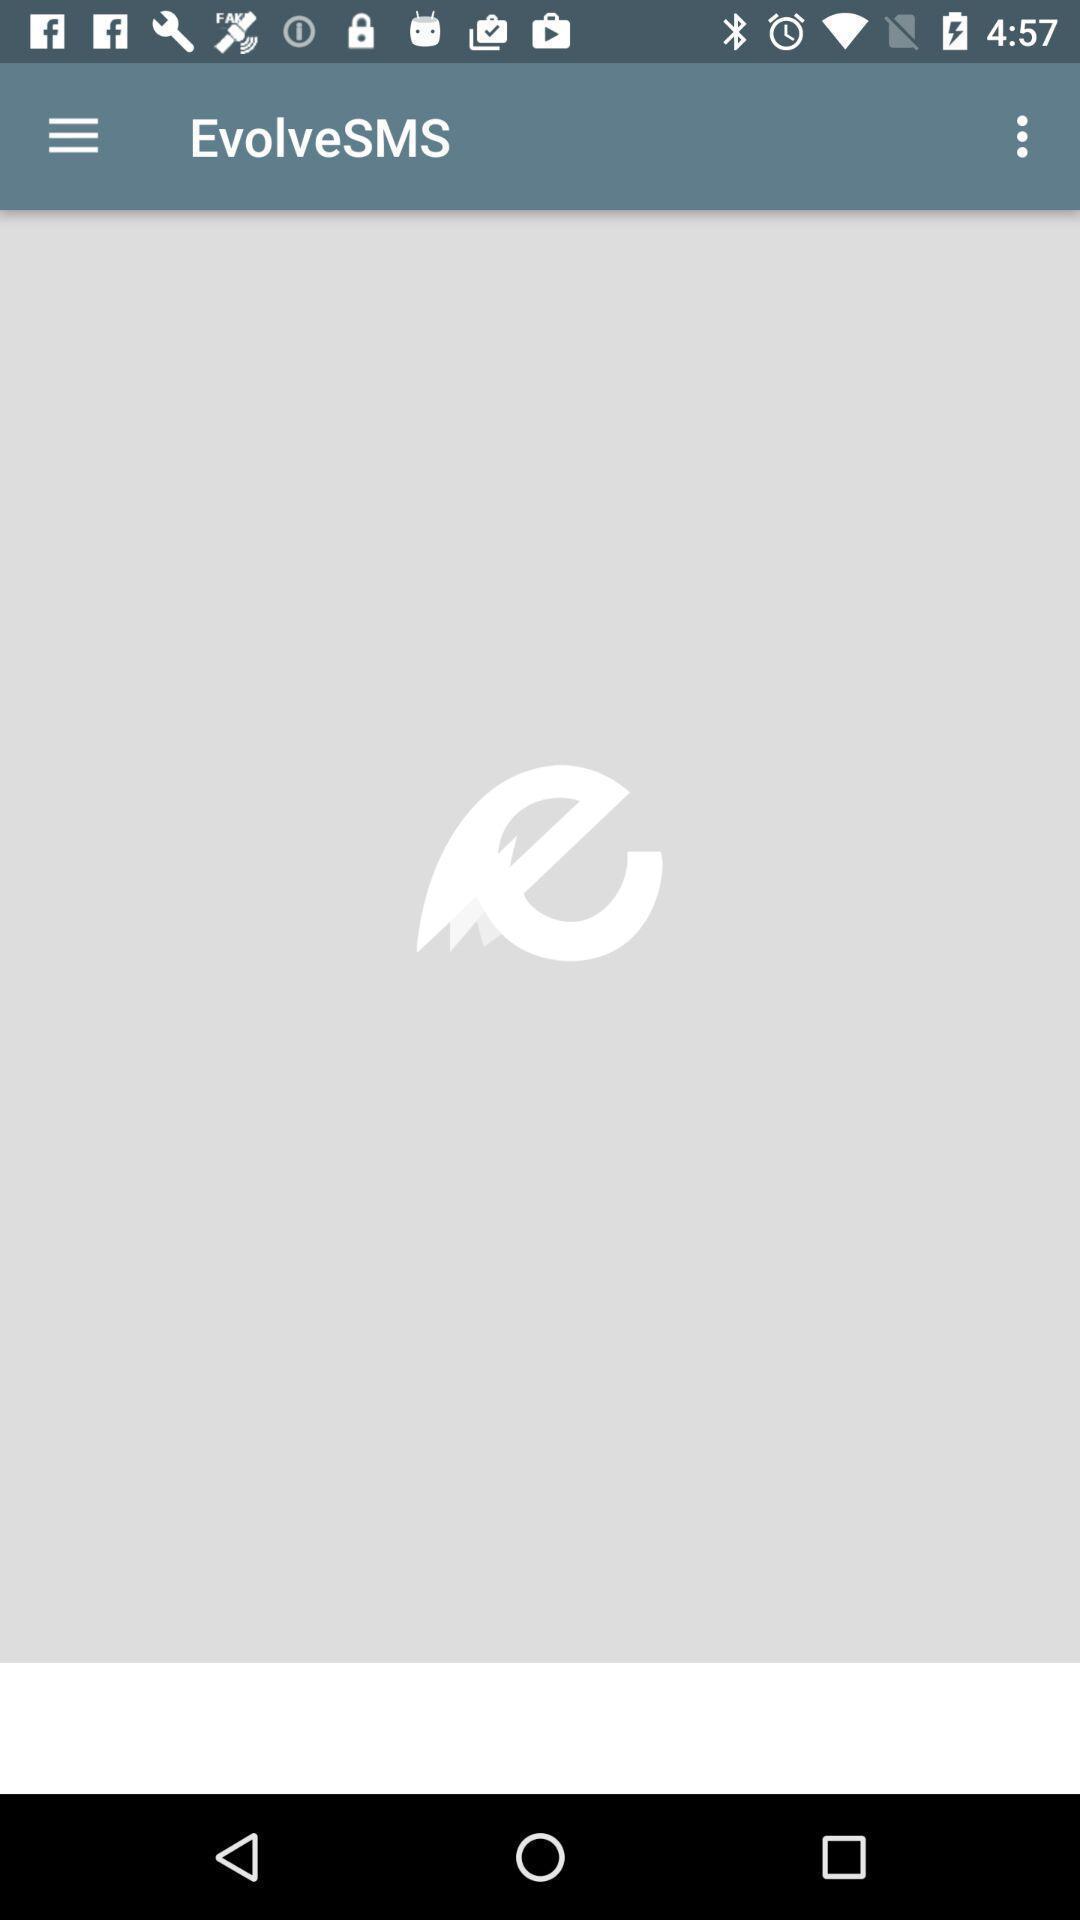Provide a description of this screenshot. Screen shows evolvesms option. 